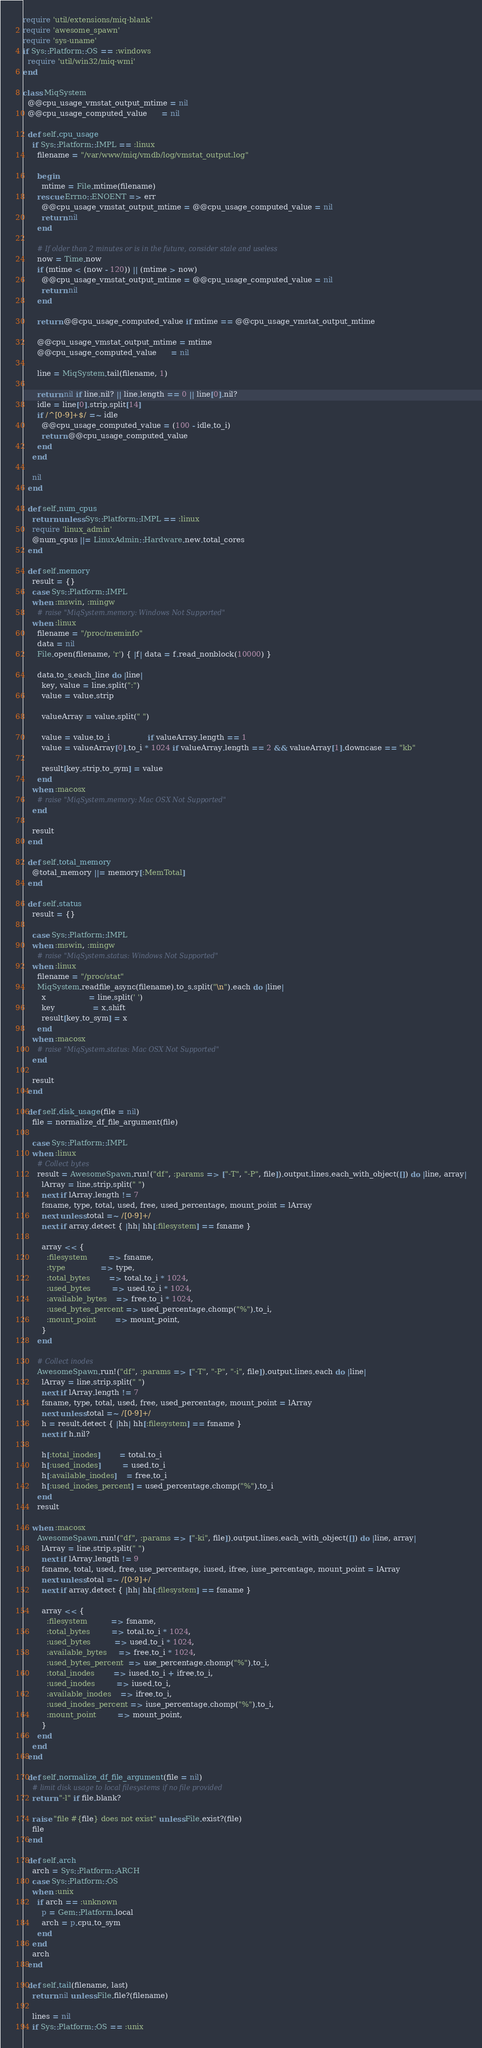Convert code to text. <code><loc_0><loc_0><loc_500><loc_500><_Ruby_>require 'util/extensions/miq-blank'
require 'awesome_spawn'
require 'sys-uname'
if Sys::Platform::OS == :windows
  require 'util/win32/miq-wmi'
end

class MiqSystem
  @@cpu_usage_vmstat_output_mtime = nil
  @@cpu_usage_computed_value      = nil

  def self.cpu_usage
    if Sys::Platform::IMPL == :linux
      filename = "/var/www/miq/vmdb/log/vmstat_output.log"

      begin
        mtime = File.mtime(filename)
      rescue Errno::ENOENT => err
        @@cpu_usage_vmstat_output_mtime = @@cpu_usage_computed_value = nil
        return nil
      end

      # If older than 2 minutes or is in the future, consider stale and useless
      now = Time.now
      if (mtime < (now - 120)) || (mtime > now)
        @@cpu_usage_vmstat_output_mtime = @@cpu_usage_computed_value = nil
        return nil
      end

      return @@cpu_usage_computed_value if mtime == @@cpu_usage_vmstat_output_mtime

      @@cpu_usage_vmstat_output_mtime = mtime
      @@cpu_usage_computed_value      = nil

      line = MiqSystem.tail(filename, 1)

      return nil if line.nil? || line.length == 0 || line[0].nil?
      idle = line[0].strip.split[14]
      if /^[0-9]+$/ =~ idle
        @@cpu_usage_computed_value = (100 - idle.to_i)
        return @@cpu_usage_computed_value
      end
    end

    nil
  end

  def self.num_cpus
    return unless Sys::Platform::IMPL == :linux
    require 'linux_admin'
    @num_cpus ||= LinuxAdmin::Hardware.new.total_cores
  end

  def self.memory
    result = {}
    case Sys::Platform::IMPL
    when :mswin, :mingw
      # raise "MiqSystem.memory: Windows Not Supported"
    when :linux
      filename = "/proc/meminfo"
      data = nil
      File.open(filename, 'r') { |f| data = f.read_nonblock(10000) }

      data.to_s.each_line do |line|
        key, value = line.split(":")
        value = value.strip

        valueArray = value.split(" ")

        value = value.to_i                if valueArray.length == 1
        value = valueArray[0].to_i * 1024 if valueArray.length == 2 && valueArray[1].downcase == "kb"

        result[key.strip.to_sym] = value
      end
    when :macosx
      # raise "MiqSystem.memory: Mac OSX Not Supported"
    end

    result
  end

  def self.total_memory
    @total_memory ||= memory[:MemTotal]
  end

  def self.status
    result = {}

    case Sys::Platform::IMPL
    when :mswin, :mingw
      # raise "MiqSystem.status: Windows Not Supported"
    when :linux
      filename = "/proc/stat"
      MiqSystem.readfile_async(filename).to_s.split("\n").each do |line|
        x                  = line.split(' ')
        key                = x.shift
        result[key.to_sym] = x
      end
    when :macosx
      # raise "MiqSystem.status: Mac OSX Not Supported"
    end

    result
  end

  def self.disk_usage(file = nil)
    file = normalize_df_file_argument(file)

    case Sys::Platform::IMPL
    when :linux
      # Collect bytes
      result = AwesomeSpawn.run!("df", :params => ["-T", "-P", file]).output.lines.each_with_object([]) do |line, array|
        lArray = line.strip.split(" ")
        next if lArray.length != 7
        fsname, type, total, used, free, used_percentage, mount_point = lArray
        next unless total =~ /[0-9]+/
        next if array.detect { |hh| hh[:filesystem] == fsname }

        array << {
          :filesystem         => fsname,
          :type               => type,
          :total_bytes        => total.to_i * 1024,
          :used_bytes         => used.to_i * 1024,
          :available_bytes    => free.to_i * 1024,
          :used_bytes_percent => used_percentage.chomp("%").to_i,
          :mount_point        => mount_point,
        }
      end

      # Collect inodes
      AwesomeSpawn.run!("df", :params => ["-T", "-P", "-i", file]).output.lines.each do |line|
        lArray = line.strip.split(" ")
        next if lArray.length != 7
        fsname, type, total, used, free, used_percentage, mount_point = lArray
        next unless total =~ /[0-9]+/
        h = result.detect { |hh| hh[:filesystem] == fsname }
        next if h.nil?

        h[:total_inodes]        = total.to_i
        h[:used_inodes]         = used.to_i
        h[:available_inodes]    = free.to_i
        h[:used_inodes_percent] = used_percentage.chomp("%").to_i
      end
      result

    when :macosx
      AwesomeSpawn.run!("df", :params => ["-ki", file]).output.lines.each_with_object([]) do |line, array|
        lArray = line.strip.split(" ")
        next if lArray.length != 9
        fsname, total, used, free, use_percentage, iused, ifree, iuse_percentage, mount_point = lArray
        next unless total =~ /[0-9]+/
        next if array.detect { |hh| hh[:filesystem] == fsname }

        array << {
          :filesystem          => fsname,
          :total_bytes         => total.to_i * 1024,
          :used_bytes          => used.to_i * 1024,
          :available_bytes     => free.to_i * 1024,
          :used_bytes_percent  => use_percentage.chomp("%").to_i,
          :total_inodes        => iused.to_i + ifree.to_i,
          :used_inodes         => iused.to_i,
          :available_inodes    => ifree.to_i,
          :used_inodes_percent => iuse_percentage.chomp("%").to_i,
          :mount_point         => mount_point,
        }
      end
    end
  end

  def self.normalize_df_file_argument(file = nil)
    # limit disk usage to local filesystems if no file provided
    return "-l" if file.blank?

    raise "file #{file} does not exist" unless File.exist?(file)
    file
  end

  def self.arch
    arch = Sys::Platform::ARCH
    case Sys::Platform::OS
    when :unix
      if arch == :unknown
        p = Gem::Platform.local
        arch = p.cpu.to_sym
      end
    end
    arch
  end

  def self.tail(filename, last)
    return nil unless File.file?(filename)

    lines = nil
    if Sys::Platform::OS == :unix</code> 